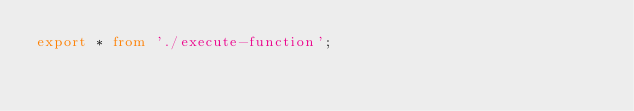<code> <loc_0><loc_0><loc_500><loc_500><_TypeScript_>export * from './execute-function';
</code> 